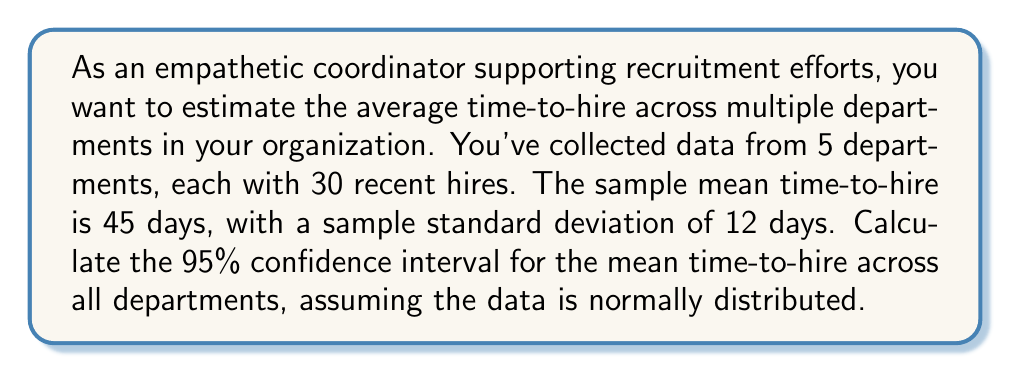Help me with this question. To calculate the confidence interval for the mean time-to-hire, we'll use the formula:

$$ \text{CI} = \bar{x} \pm t_{\alpha/2, df} \cdot \frac{s}{\sqrt{n}} $$

Where:
- $\bar{x}$ is the sample mean (45 days)
- $s$ is the sample standard deviation (12 days)
- $n$ is the total sample size (5 departments × 30 hires = 150)
- $t_{\alpha/2, df}$ is the t-value for a 95% confidence level with df = n - 1

Steps:
1) Calculate degrees of freedom: $df = n - 1 = 150 - 1 = 149$

2) Find $t_{\alpha/2, df}$ for 95% confidence level and df = 149:
   $t_{0.025, 149} \approx 1.976$ (from t-distribution table)

3) Calculate the standard error of the mean:
   $SE = \frac{s}{\sqrt{n}} = \frac{12}{\sqrt{150}} \approx 0.9798$

4) Calculate the margin of error:
   $ME = t_{\alpha/2, df} \cdot SE = 1.976 \cdot 0.9798 \approx 1.9361$

5) Calculate the confidence interval:
   $CI = \bar{x} \pm ME = 45 \pm 1.9361$

Therefore, the 95% confidence interval is approximately (43.0639, 46.9361) days.
Answer: The 95% confidence interval for the mean time-to-hire across all departments is approximately (43.06, 46.94) days. 